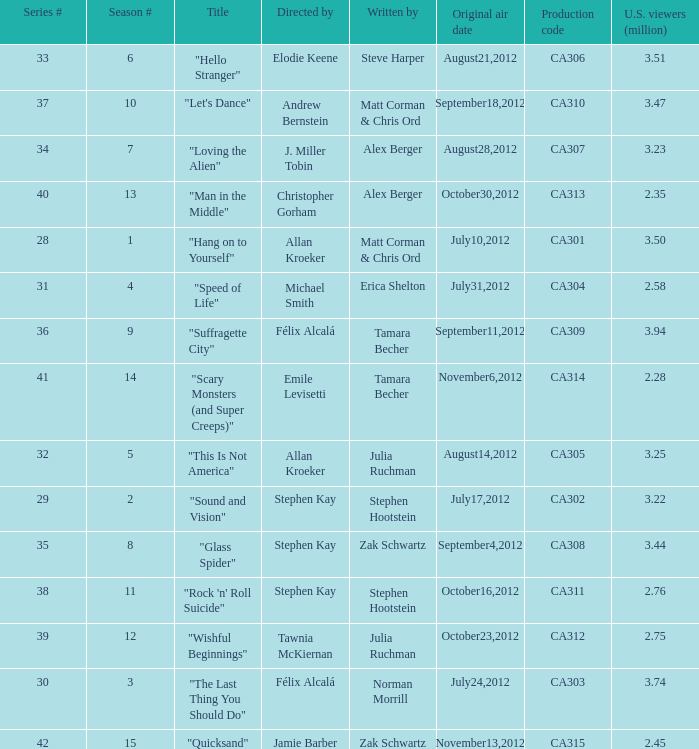Could you help me parse every detail presented in this table? {'header': ['Series #', 'Season #', 'Title', 'Directed by', 'Written by', 'Original air date', 'Production code', 'U.S. viewers (million)'], 'rows': [['33', '6', '"Hello Stranger"', 'Elodie Keene', 'Steve Harper', 'August21,2012', 'CA306', '3.51'], ['37', '10', '"Let\'s Dance"', 'Andrew Bernstein', 'Matt Corman & Chris Ord', 'September18,2012', 'CA310', '3.47'], ['34', '7', '"Loving the Alien"', 'J. Miller Tobin', 'Alex Berger', 'August28,2012', 'CA307', '3.23'], ['40', '13', '"Man in the Middle"', 'Christopher Gorham', 'Alex Berger', 'October30,2012', 'CA313', '2.35'], ['28', '1', '"Hang on to Yourself"', 'Allan Kroeker', 'Matt Corman & Chris Ord', 'July10,2012', 'CA301', '3.50'], ['31', '4', '"Speed of Life"', 'Michael Smith', 'Erica Shelton', 'July31,2012', 'CA304', '2.58'], ['36', '9', '"Suffragette City"', 'Félix Alcalá', 'Tamara Becher', 'September11,2012', 'CA309', '3.94'], ['41', '14', '"Scary Monsters (and Super Creeps)"', 'Emile Levisetti', 'Tamara Becher', 'November6,2012', 'CA314', '2.28'], ['32', '5', '"This Is Not America"', 'Allan Kroeker', 'Julia Ruchman', 'August14,2012', 'CA305', '3.25'], ['29', '2', '"Sound and Vision"', 'Stephen Kay', 'Stephen Hootstein', 'July17,2012', 'CA302', '3.22'], ['35', '8', '"Glass Spider"', 'Stephen Kay', 'Zak Schwartz', 'September4,2012', 'CA308', '3.44'], ['38', '11', '"Rock \'n\' Roll Suicide"', 'Stephen Kay', 'Stephen Hootstein', 'October16,2012', 'CA311', '2.76'], ['39', '12', '"Wishful Beginnings"', 'Tawnia McKiernan', 'Julia Ruchman', 'October23,2012', 'CA312', '2.75'], ['30', '3', '"The Last Thing You Should Do"', 'Félix Alcalá', 'Norman Morrill', 'July24,2012', 'CA303', '3.74'], ['42', '15', '"Quicksand"', 'Jamie Barber', 'Zak Schwartz', 'November13,2012', 'CA315', '2.45']]} Who directed the episode with production code ca303? Félix Alcalá. 